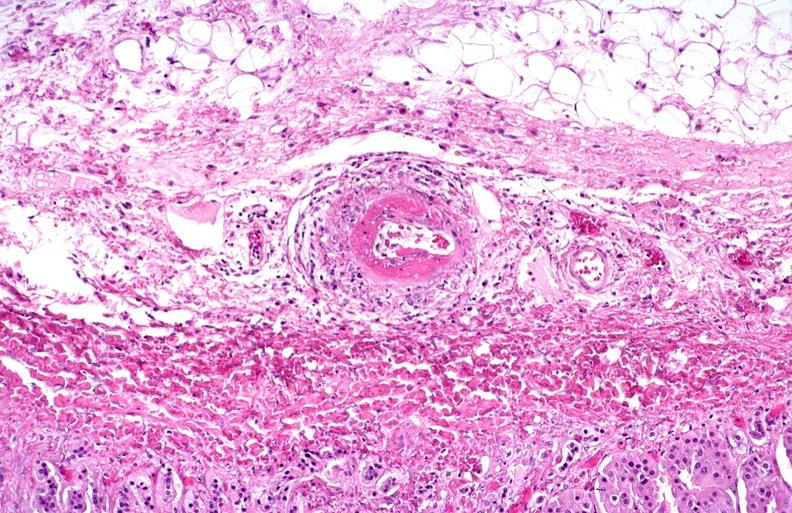what is present?
Answer the question using a single word or phrase. Cardiovascular 